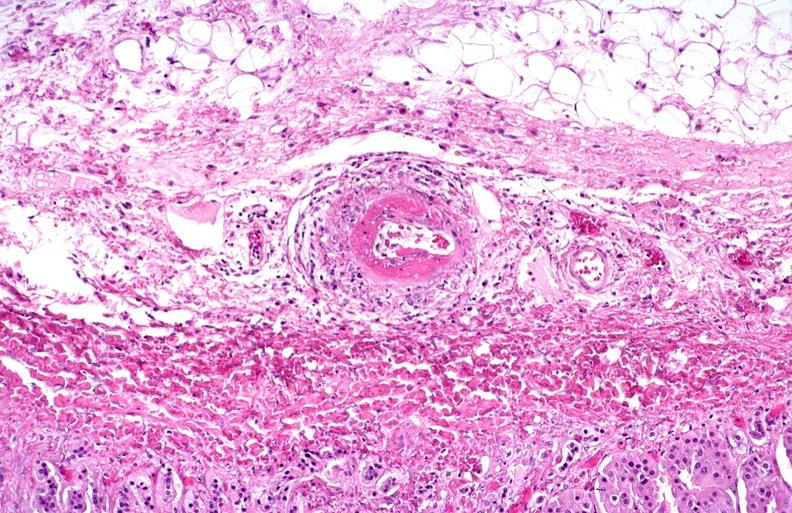what is present?
Answer the question using a single word or phrase. Cardiovascular 